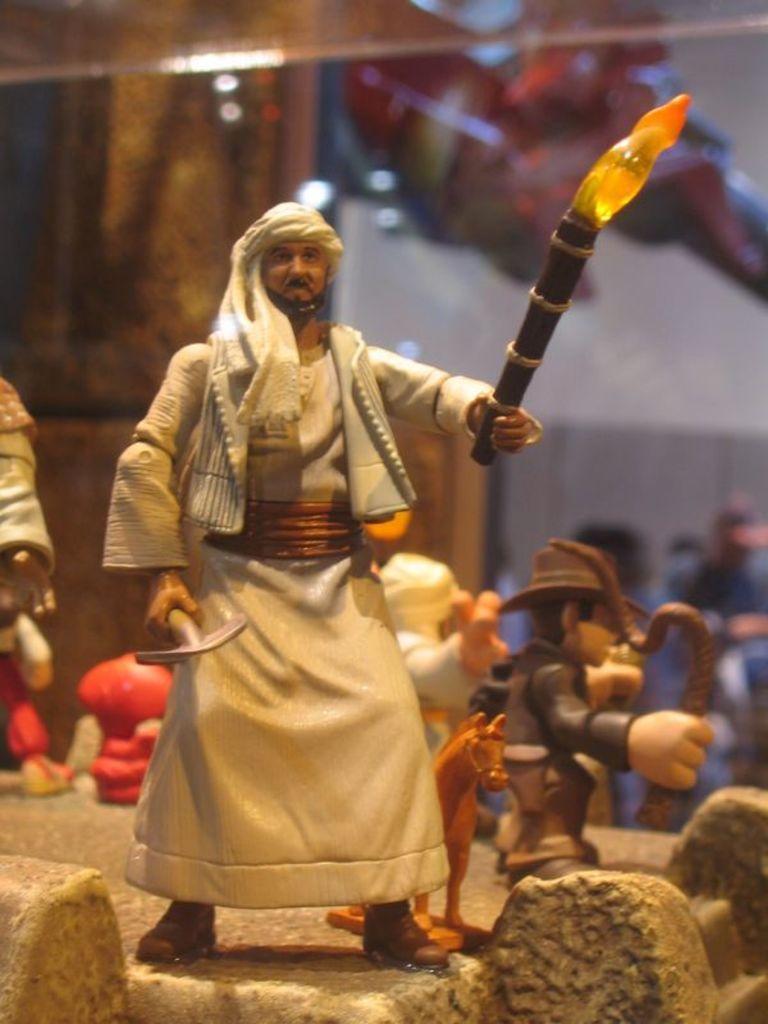How would you summarize this image in a sentence or two? In this image, I can see the toys. This is the man standing and holding a tool and a stick with the fire in his hands. This looks like a horse. The background looks blurry. 